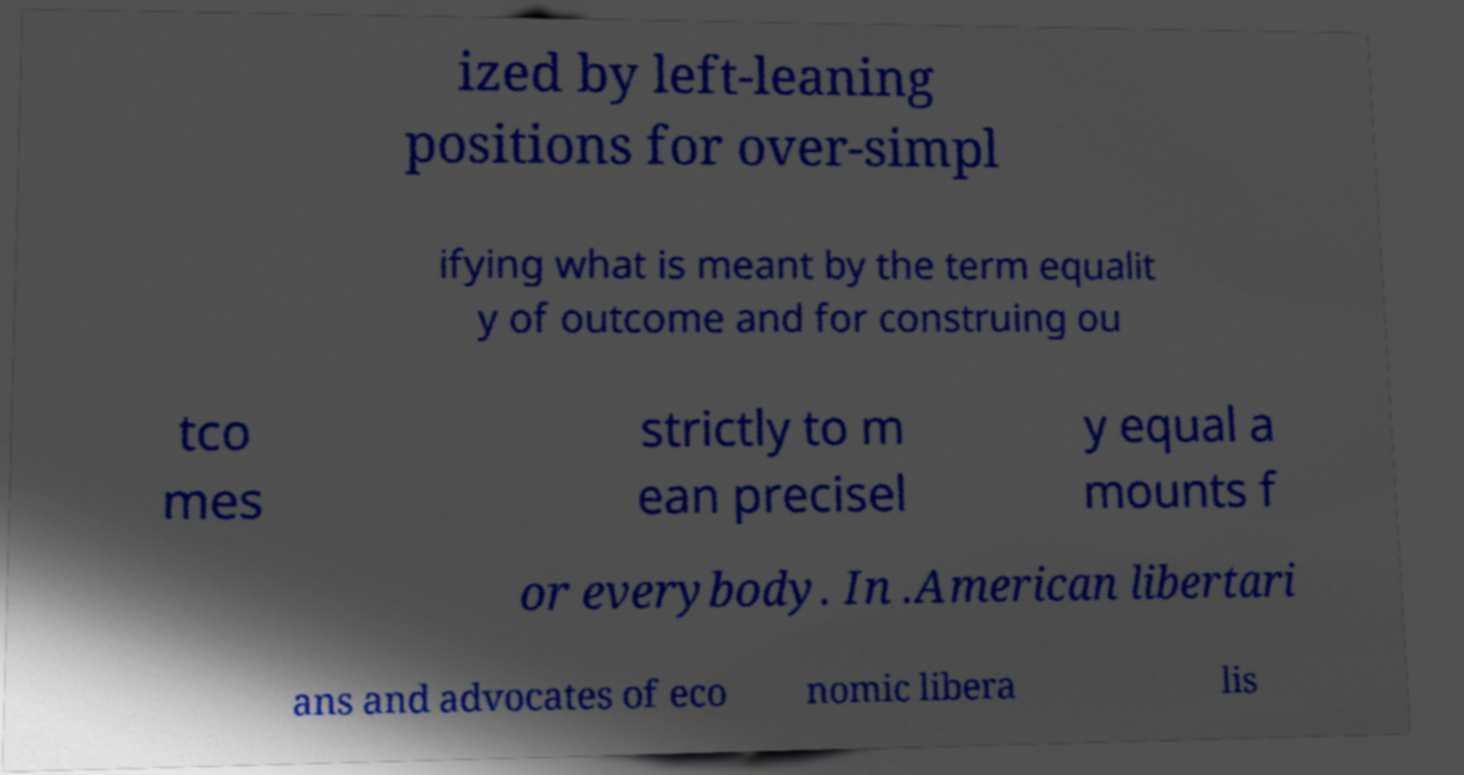Could you assist in decoding the text presented in this image and type it out clearly? ized by left-leaning positions for over-simpl ifying what is meant by the term equalit y of outcome and for construing ou tco mes strictly to m ean precisel y equal a mounts f or everybody. In .American libertari ans and advocates of eco nomic libera lis 